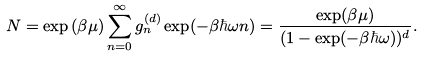Convert formula to latex. <formula><loc_0><loc_0><loc_500><loc_500>N = \exp { ( \beta \mu ) } \sum _ { n = 0 } ^ { \infty } g _ { n } ^ { ( d ) } \exp ( - \beta \hbar { \omega } n ) = \frac { \exp ( \beta \mu ) } { ( 1 - \exp ( - \beta \hbar { \omega } ) ) ^ { d } } .</formula> 